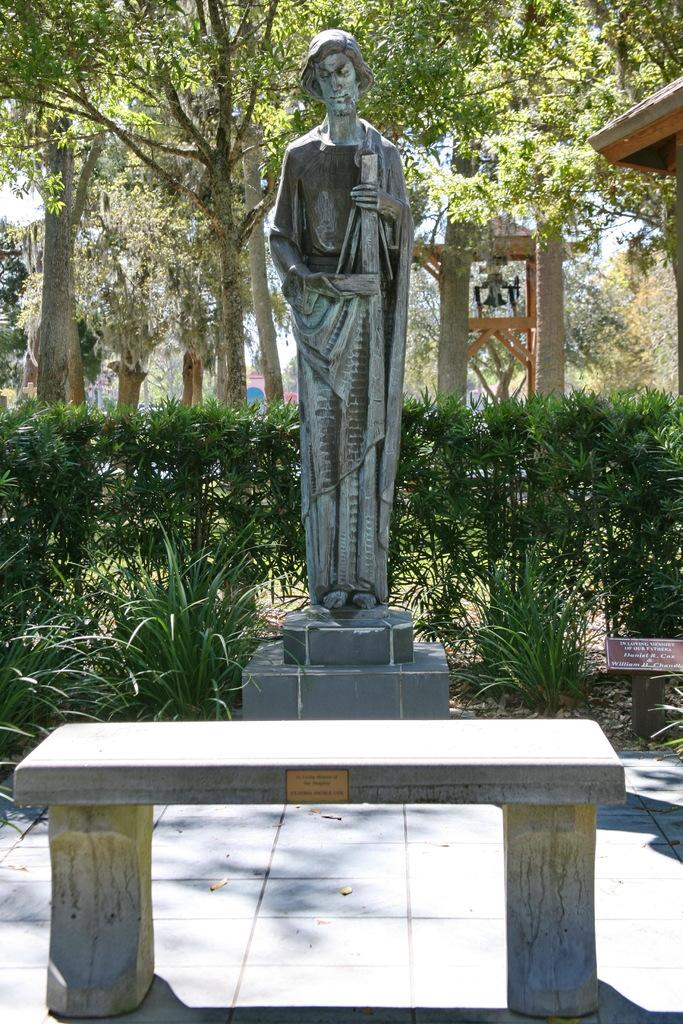What is the main subject in the image? There is a statue in the image. What other objects can be seen in the image? There is a small tree and a chair in the image. What year is depicted on the statue in the image? The provided facts do not mention any specific year or date related to the statue, so it cannot be determined from the image. 